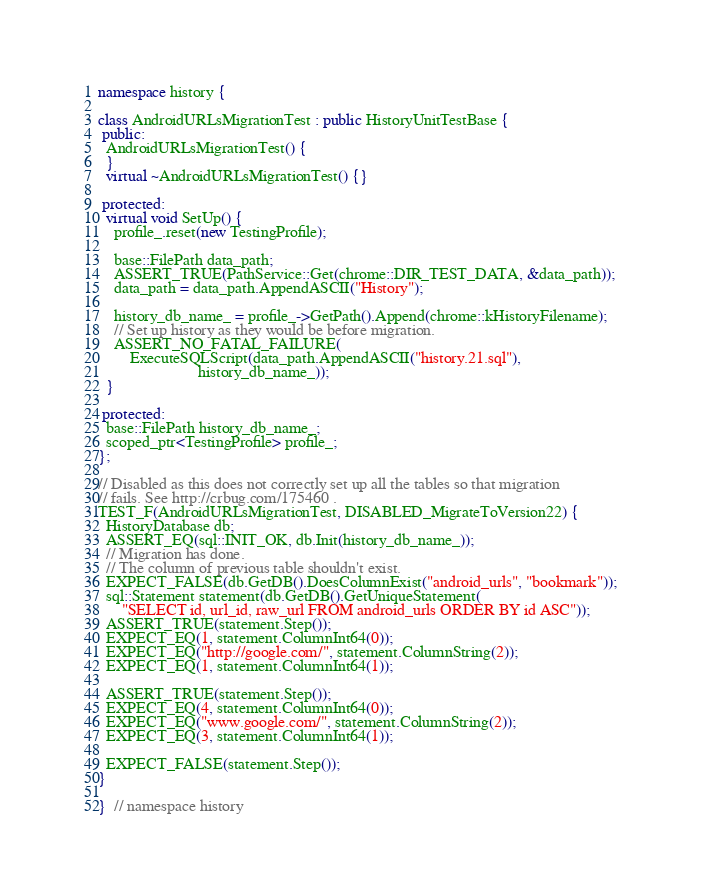Convert code to text. <code><loc_0><loc_0><loc_500><loc_500><_C++_>
namespace history {

class AndroidURLsMigrationTest : public HistoryUnitTestBase {
 public:
  AndroidURLsMigrationTest() {
  }
  virtual ~AndroidURLsMigrationTest() {}

 protected:
  virtual void SetUp() {
    profile_.reset(new TestingProfile);

    base::FilePath data_path;
    ASSERT_TRUE(PathService::Get(chrome::DIR_TEST_DATA, &data_path));
    data_path = data_path.AppendASCII("History");

    history_db_name_ = profile_->GetPath().Append(chrome::kHistoryFilename);
    // Set up history as they would be before migration.
    ASSERT_NO_FATAL_FAILURE(
        ExecuteSQLScript(data_path.AppendASCII("history.21.sql"),
                         history_db_name_));
  }

 protected:
  base::FilePath history_db_name_;
  scoped_ptr<TestingProfile> profile_;
};

// Disabled as this does not correctly set up all the tables so that migration
// fails. See http://crbug.com/175460 .
TEST_F(AndroidURLsMigrationTest, DISABLED_MigrateToVersion22) {
  HistoryDatabase db;
  ASSERT_EQ(sql::INIT_OK, db.Init(history_db_name_));
  // Migration has done.
  // The column of previous table shouldn't exist.
  EXPECT_FALSE(db.GetDB().DoesColumnExist("android_urls", "bookmark"));
  sql::Statement statement(db.GetDB().GetUniqueStatement(
      "SELECT id, url_id, raw_url FROM android_urls ORDER BY id ASC"));
  ASSERT_TRUE(statement.Step());
  EXPECT_EQ(1, statement.ColumnInt64(0));
  EXPECT_EQ("http://google.com/", statement.ColumnString(2));
  EXPECT_EQ(1, statement.ColumnInt64(1));

  ASSERT_TRUE(statement.Step());
  EXPECT_EQ(4, statement.ColumnInt64(0));
  EXPECT_EQ("www.google.com/", statement.ColumnString(2));
  EXPECT_EQ(3, statement.ColumnInt64(1));

  EXPECT_FALSE(statement.Step());
}

}  // namespace history
</code> 